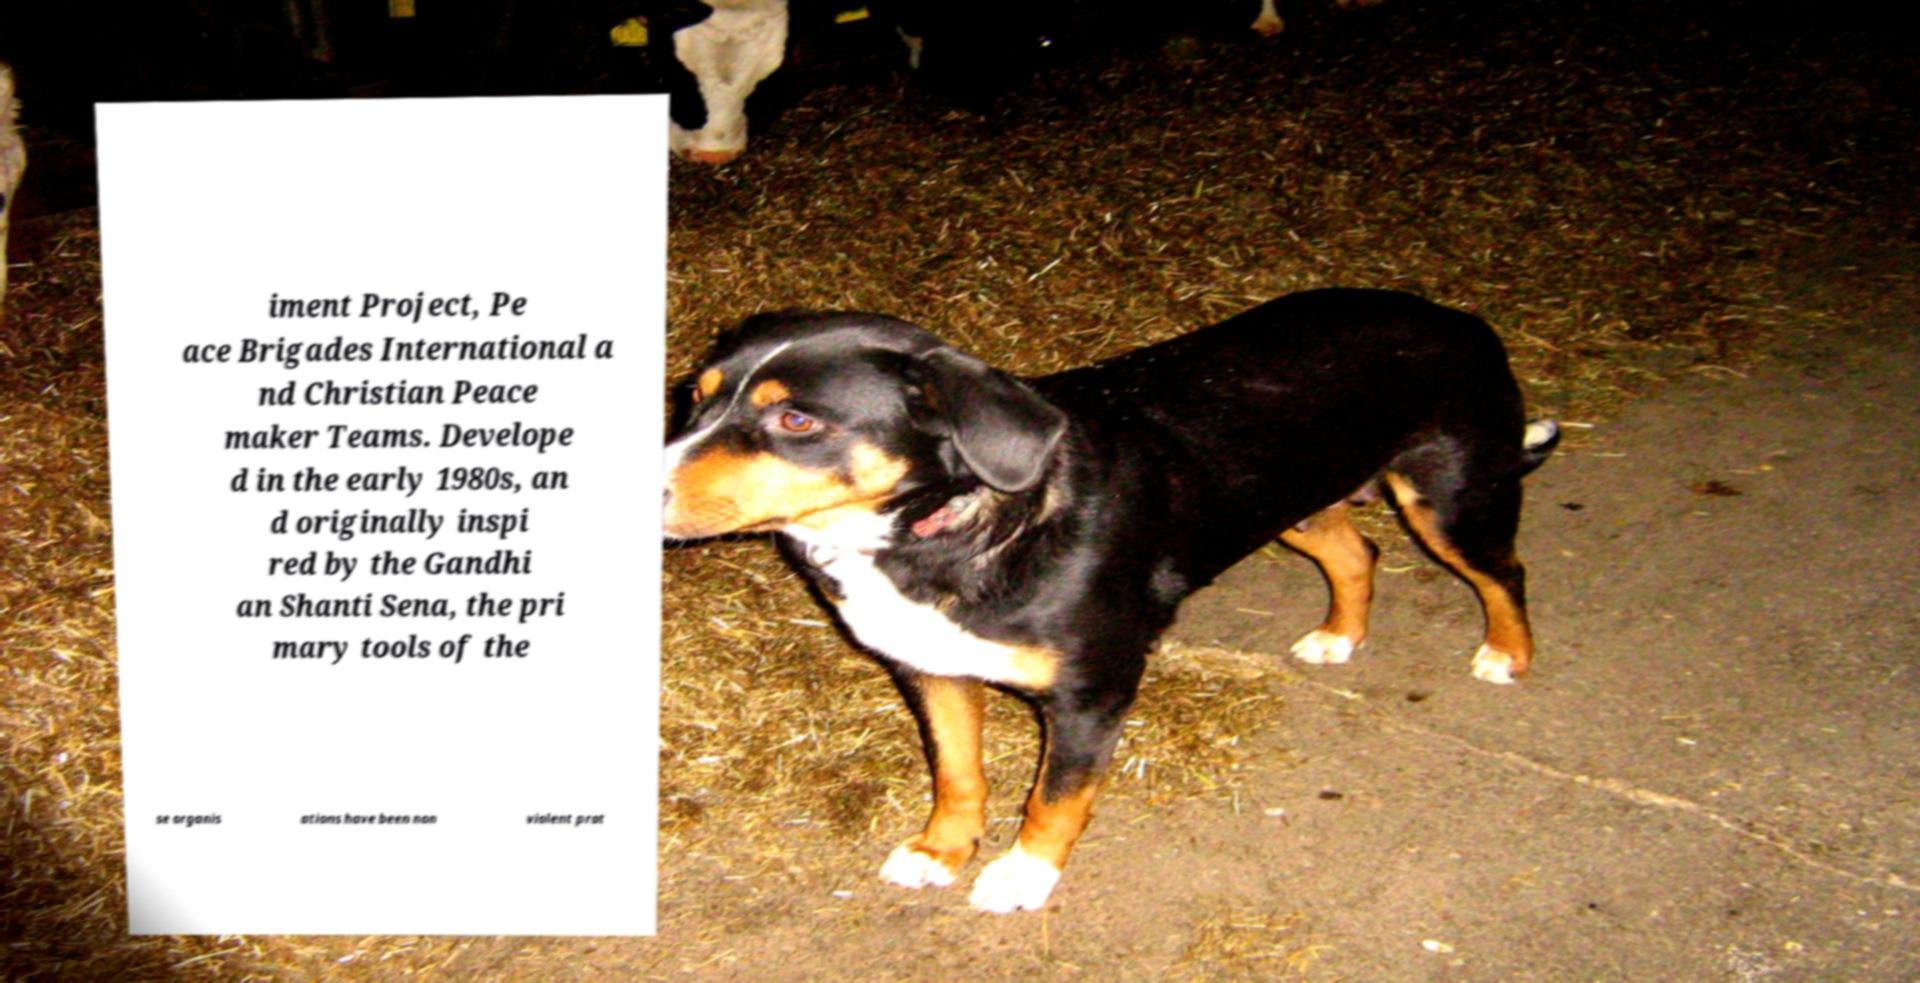Please read and relay the text visible in this image. What does it say? iment Project, Pe ace Brigades International a nd Christian Peace maker Teams. Develope d in the early 1980s, an d originally inspi red by the Gandhi an Shanti Sena, the pri mary tools of the se organis ations have been non violent prot 